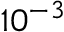<formula> <loc_0><loc_0><loc_500><loc_500>1 0 ^ { - 3 }</formula> 